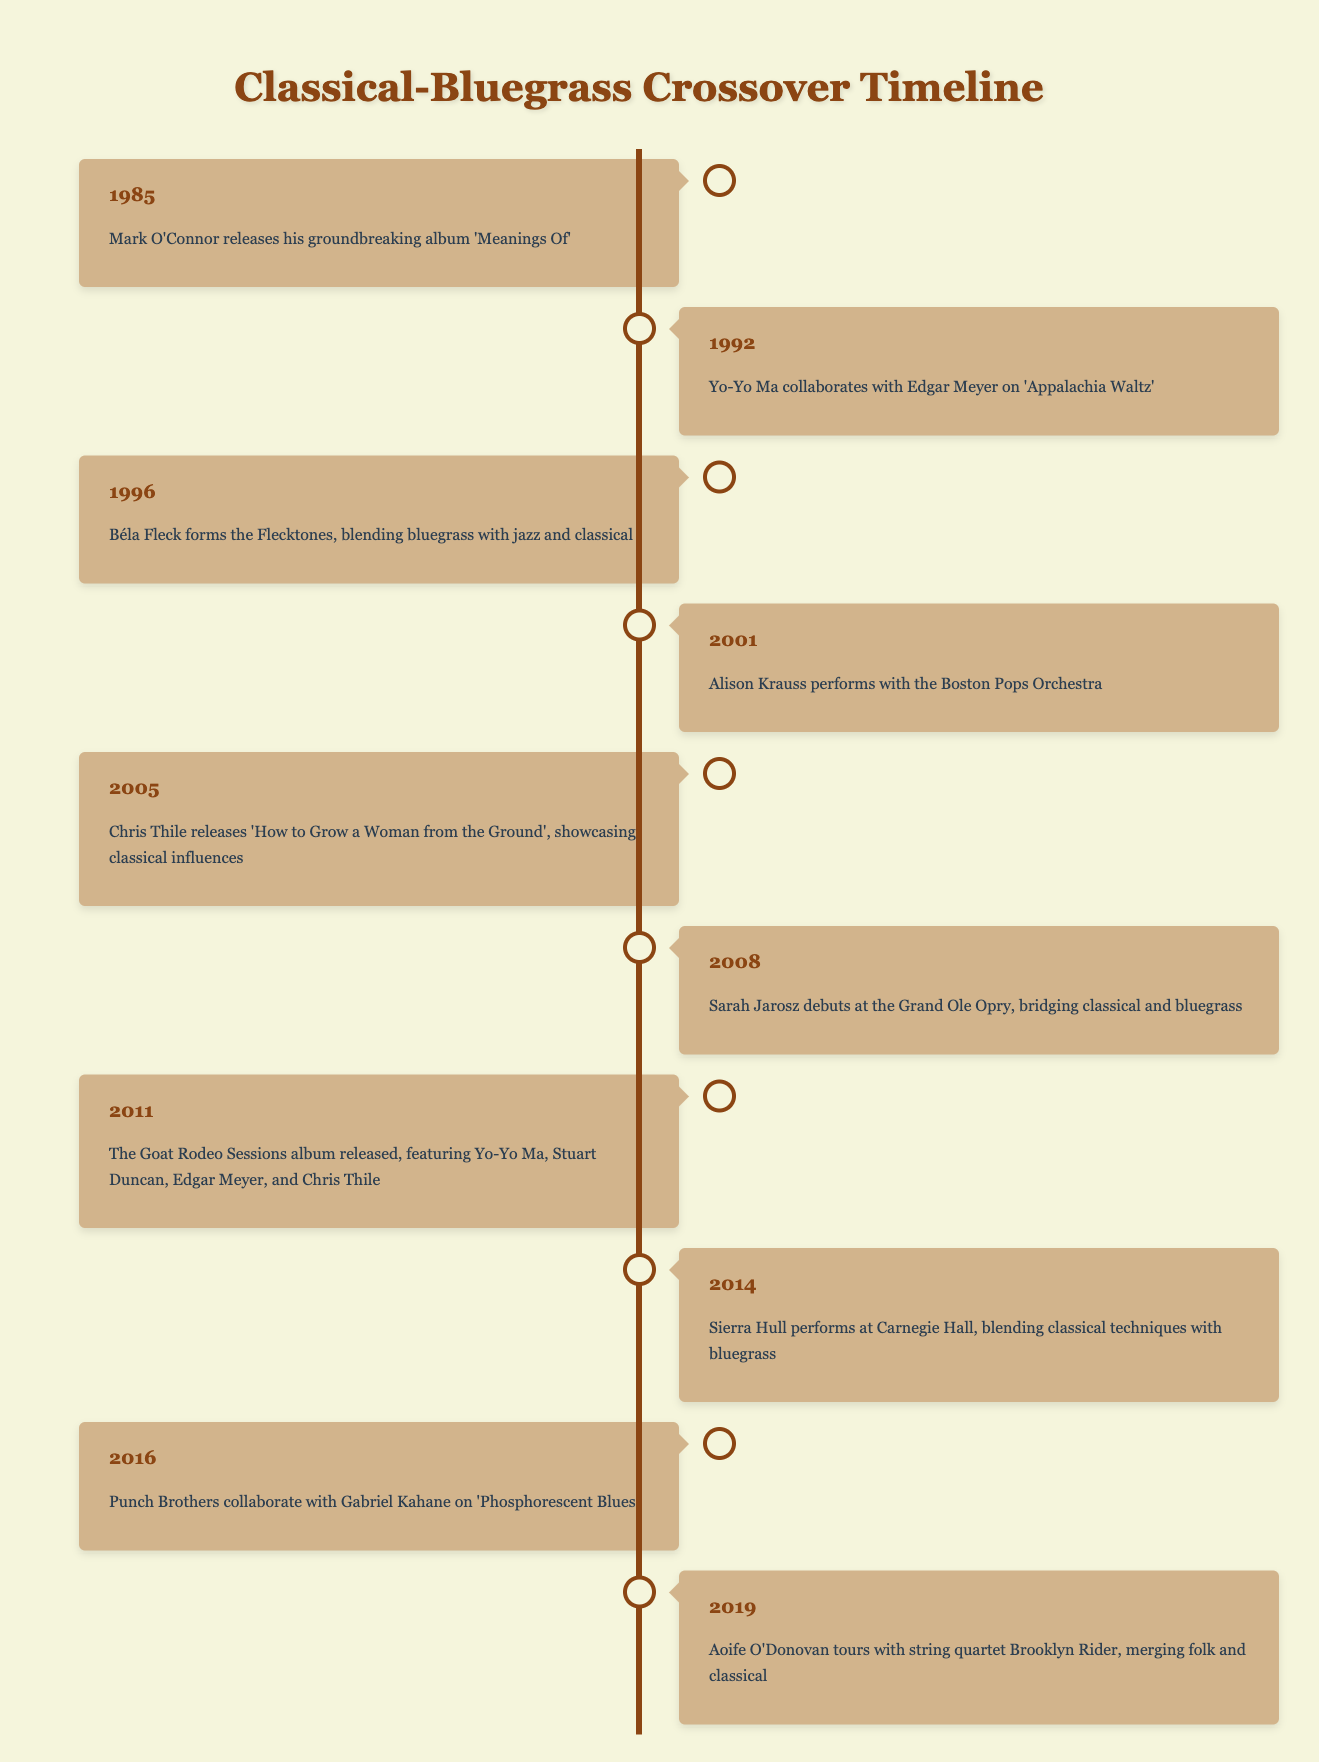What year did Mark O'Connor release 'Meanings Of'? Referring to the timeline, Mark O'Connor's event is listed under the year 1985, which indicates that he released the album that year.
Answer: 1985 Which artist collaborated with Edgar Meyer in 1992? According to the timeline, Yo-Yo Ma is mentioned specifically as collaborating with Edgar Meyer on the album 'Appalachia Waltz' in 1992.
Answer: Yo-Yo Ma How many events occurred between 2001 and 2014? The events within this range are for the years 2001 (Alison Krauss), 2005 (Chris Thile), 2008 (Sarah Jarosz), 2011 (Goat Rodeo Sessions), and 2014 (Sierra Hull). This gives us a total of four events (2005, 2008, 2011, 2014).
Answer: 4 Did Chris Thile's album in 2005 showcase classical influences? The entry for 2005 states that Chris Thile released 'How to Grow a Woman from the Ground', showcasing classical influences, confirming that this statement is true.
Answer: Yes What was the earliest collaboration mentioned in the timeline? By examining the events in chronological order, the first collaboration was between Yo-Yo Ma and Edgar Meyer in 1992, making it the earliest noted collaboration in the table.
Answer: Yo-Yo Ma and Edgar Meyer in 1992 Which artist performed at Carnegie Hall and what year did it happen? The timeline indicates that Sierra Hull performed at Carnegie Hall in the year 2014.
Answer: Sierra Hull in 2014 What is the total number of artists mentioned in the timeline? Counting unique names: Mark O'Connor, Yo-Yo Ma, Edgar Meyer, Béla Fleck, Alison Krauss, Chris Thile, Sarah Jarosz, Stuart Duncan, Sierra Hull, Gabriel Kahane, and Aoife O'Donovan yield a total of 11 artists mentioned.
Answer: 11 Which year had two events related to collaborations? In 2011, The Goat Rodeo Sessions album released, which involved multiple artists and can be classified as a collaboration-related event. This is the only year that features multiple artists noted for collaboration.
Answer: 2011 How many years are between the first event in 1985 and the last event in 2019? Subtracting 1985 from 2019 gives 34 years. Therefore, there are 34 years between the first and last events listed on the timeline.
Answer: 34 